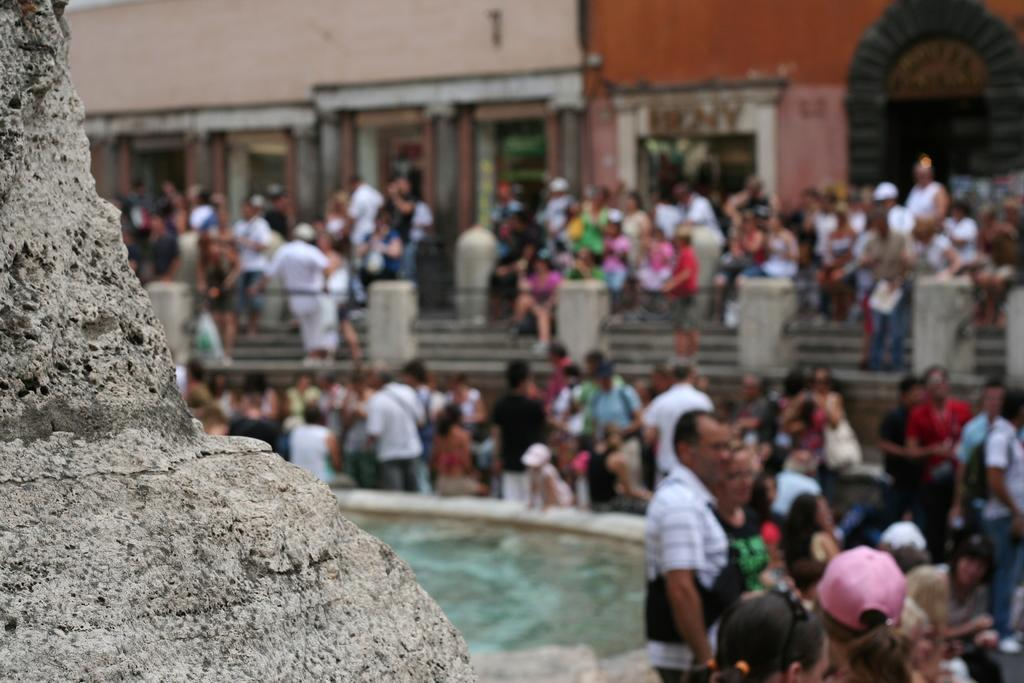What type of natural elements can be seen in the image? There are stones and water visible in the image. Can you describe the people in the image? There are people in the image, but their specific actions or characteristics are not mentioned in the provided facts. What is visible in the background of the image? The background of the image is blurry, but a wall and a fence can be seen. What type of floor can be seen in the image? There is no mention of a floor in the provided facts, as the image features stones and water. What is the governor's opinion on the situation depicted in the image? There is no information about the governor or any authority figures in the image or the provided facts. 